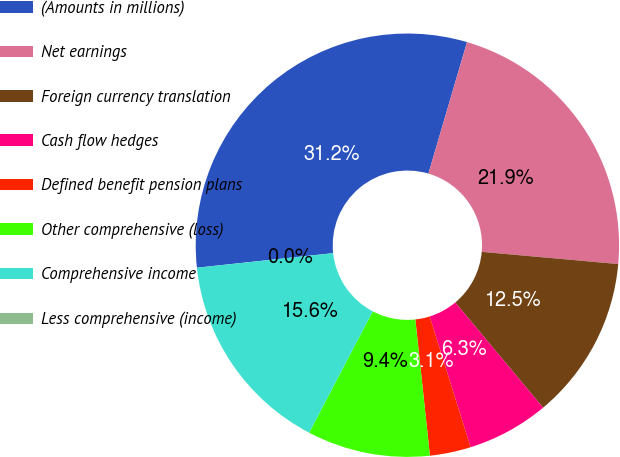<chart> <loc_0><loc_0><loc_500><loc_500><pie_chart><fcel>(Amounts in millions)<fcel>Net earnings<fcel>Foreign currency translation<fcel>Cash flow hedges<fcel>Defined benefit pension plans<fcel>Other comprehensive (loss)<fcel>Comprehensive income<fcel>Less comprehensive (income)<nl><fcel>31.24%<fcel>21.87%<fcel>12.5%<fcel>6.25%<fcel>3.13%<fcel>9.38%<fcel>15.62%<fcel>0.0%<nl></chart> 